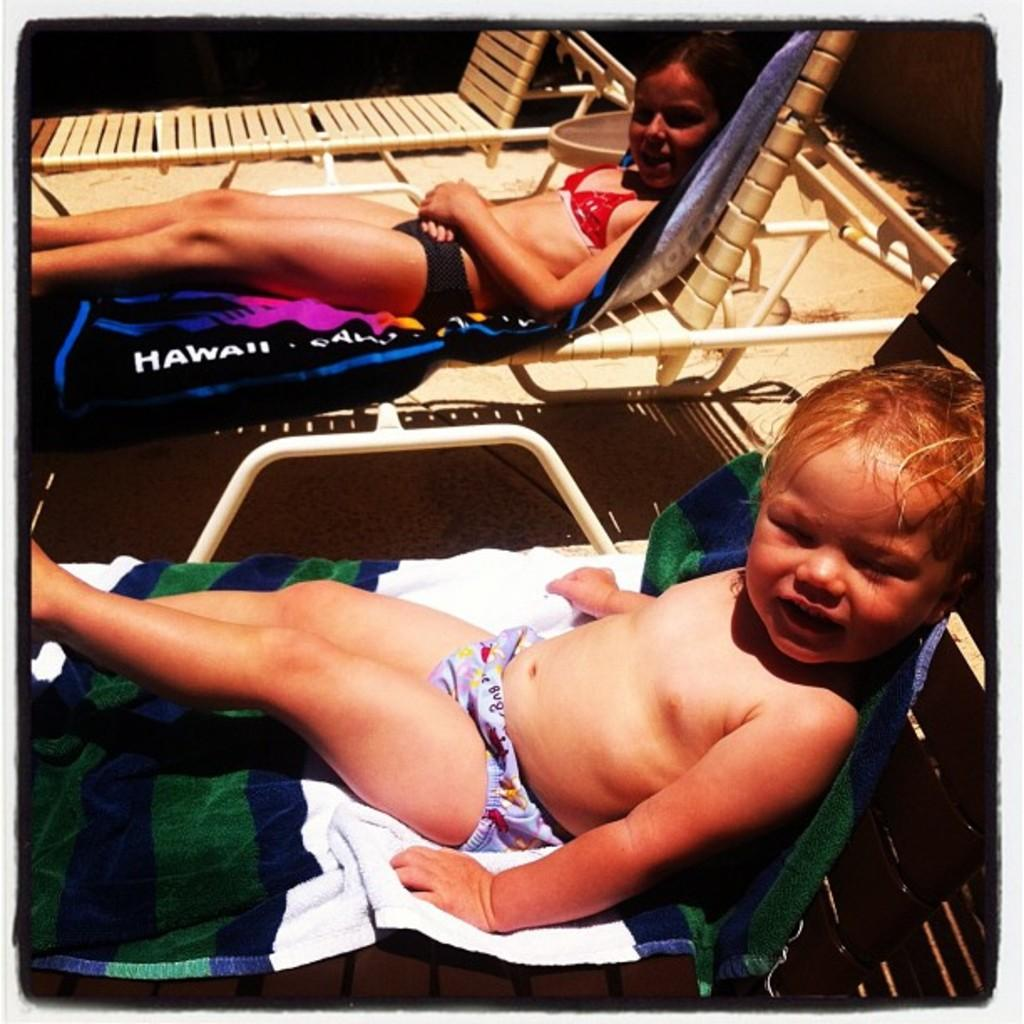How many kids are in the image? There are two kids in the image. What are the kids doing in the image? The kids are sleeping on a chair. What are the kids wearing in the image? The kids are wearing swimsuits. How many chairs are in the image? There are three chairs in the image. How are the chairs arranged in the image? The chairs are placed side by side. What are the kids sleeping on in the image? The kids are sleeping on towels. Can you see any wounds on the kids in the image? There is no mention of any wounds on the kids in the image. 